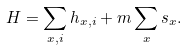Convert formula to latex. <formula><loc_0><loc_0><loc_500><loc_500>H = \sum _ { x , i } h _ { x , i } + m \sum _ { x } s _ { x } .</formula> 